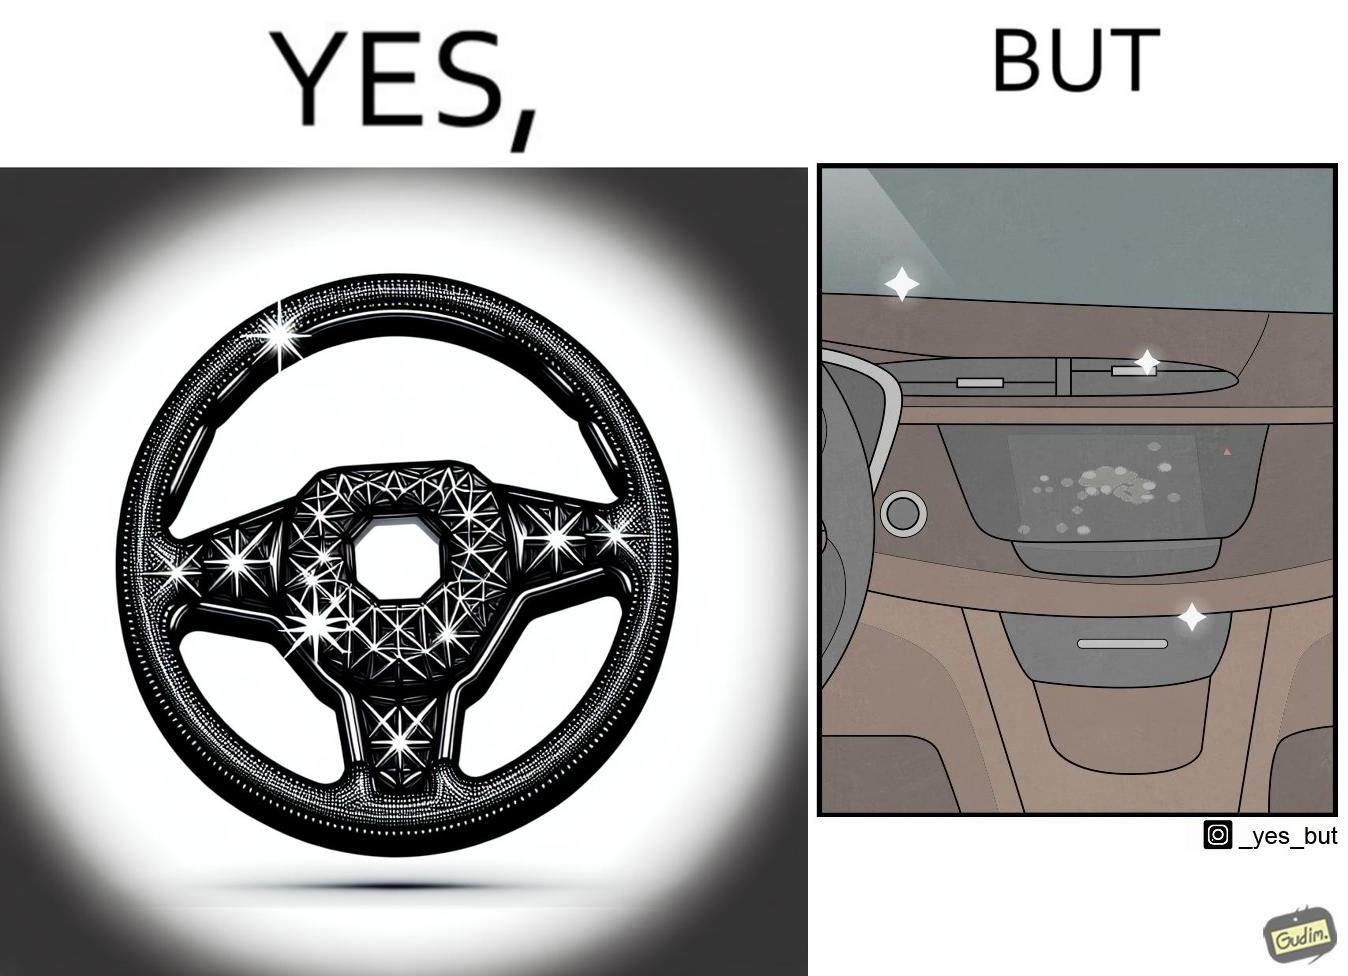Is there satirical content in this image? Yes, this image is satirical. 